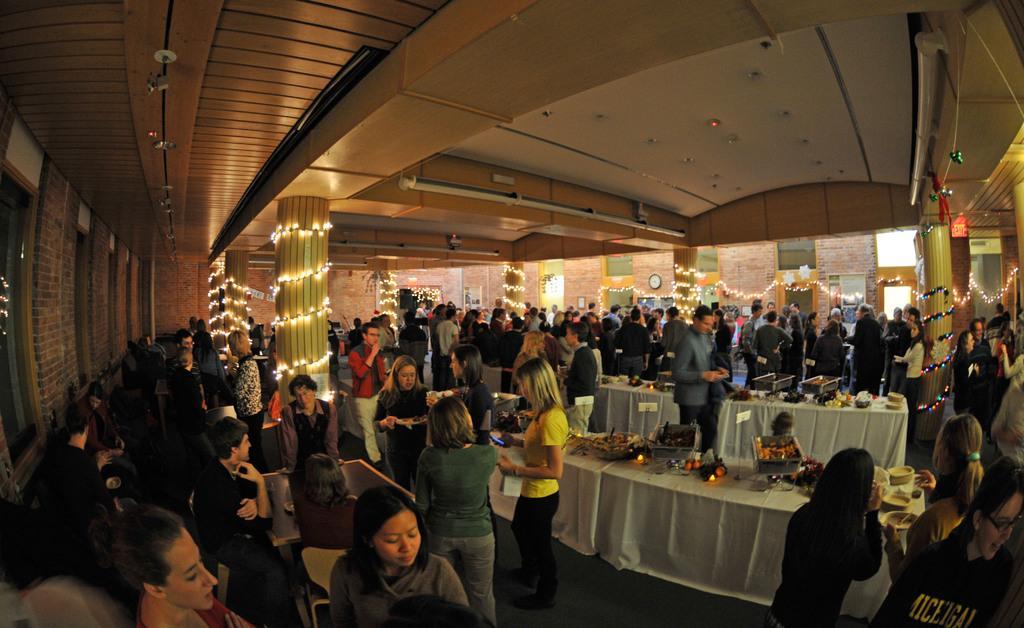How would you summarize this image in a sentence or two? In this image there are group of people standing and sitting on the chairs , and there are some items on the tables with the name boards , rope lights , pillars, windows, lights. 